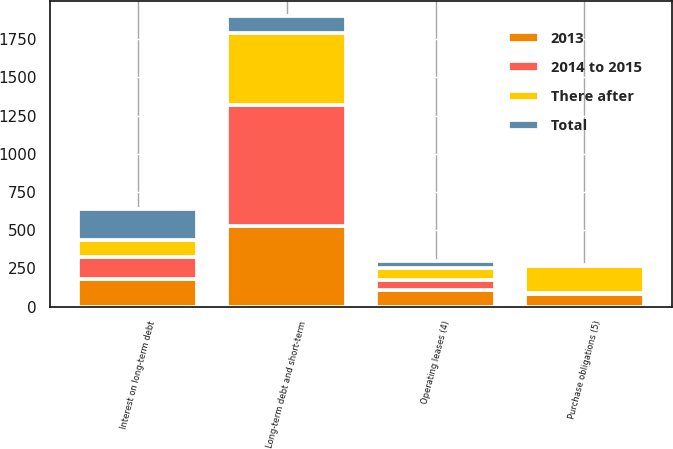Convert chart. <chart><loc_0><loc_0><loc_500><loc_500><stacked_bar_chart><ecel><fcel>Long-term debt and short-term<fcel>Interest on long-term debt<fcel>Operating leases (4)<fcel>Purchase obligations (5)<nl><fcel>There after<fcel>474<fcel>106<fcel>83<fcel>175<nl><fcel>2013<fcel>526<fcel>184<fcel>112<fcel>84<nl><fcel>2014 to 2015<fcel>792<fcel>143<fcel>60<fcel>6<nl><fcel>Total<fcel>112<fcel>205<fcel>45<fcel>5<nl></chart> 